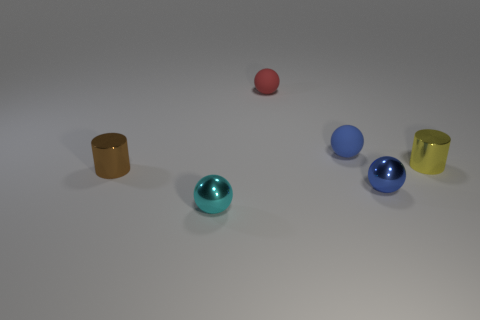What is the shape of the blue object that is in front of the small yellow metal thing?
Offer a terse response. Sphere. What is the material of the cylinder that is behind the small shiny cylinder that is on the left side of the cylinder that is to the right of the tiny blue metal sphere?
Provide a succinct answer. Metal. What number of other things are there of the same size as the cyan object?
Make the answer very short. 5. There is a red object that is the same shape as the cyan metallic thing; what material is it?
Make the answer very short. Rubber. There is a small cylinder that is right of the small cylinder that is left of the tiny cyan thing; what color is it?
Make the answer very short. Yellow. How many tiny cyan things are behind the shiny cylinder that is behind the metallic cylinder that is to the left of the yellow shiny object?
Give a very brief answer. 0. There is a brown cylinder; are there any small yellow cylinders right of it?
Give a very brief answer. Yes. What number of cubes are either tiny red objects or metallic things?
Offer a terse response. 0. What number of metal objects are both right of the blue metallic object and to the left of the small red object?
Make the answer very short. 0. Are there an equal number of cylinders to the right of the red sphere and small red things right of the blue rubber thing?
Ensure brevity in your answer.  No. 